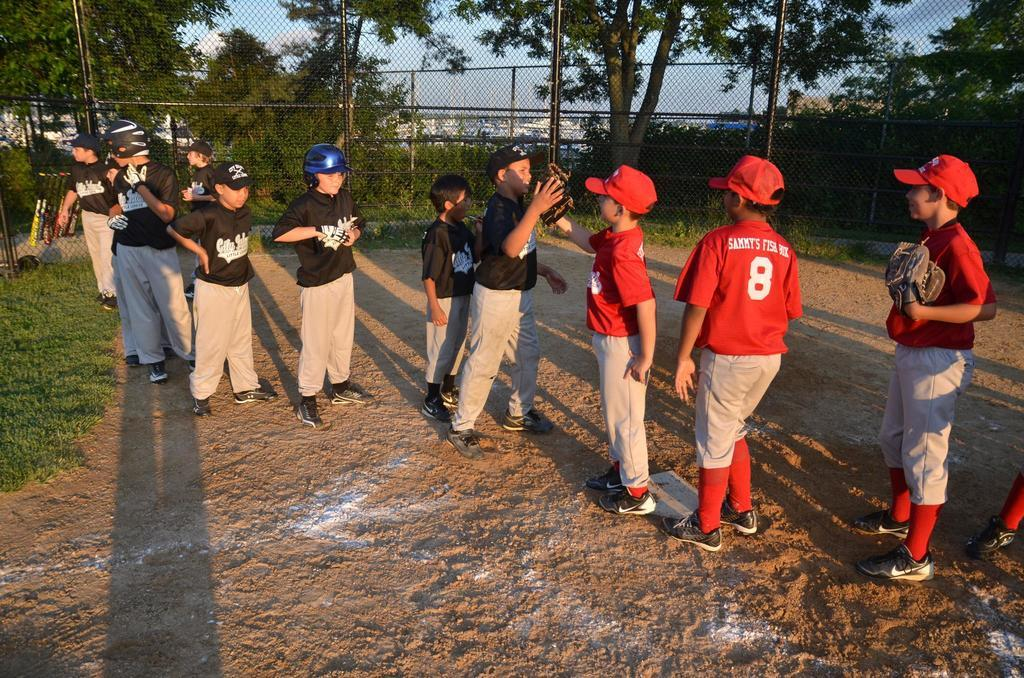Provide a one-sentence caption for the provided image. The player who's number is eight has Sammy's on his back. 